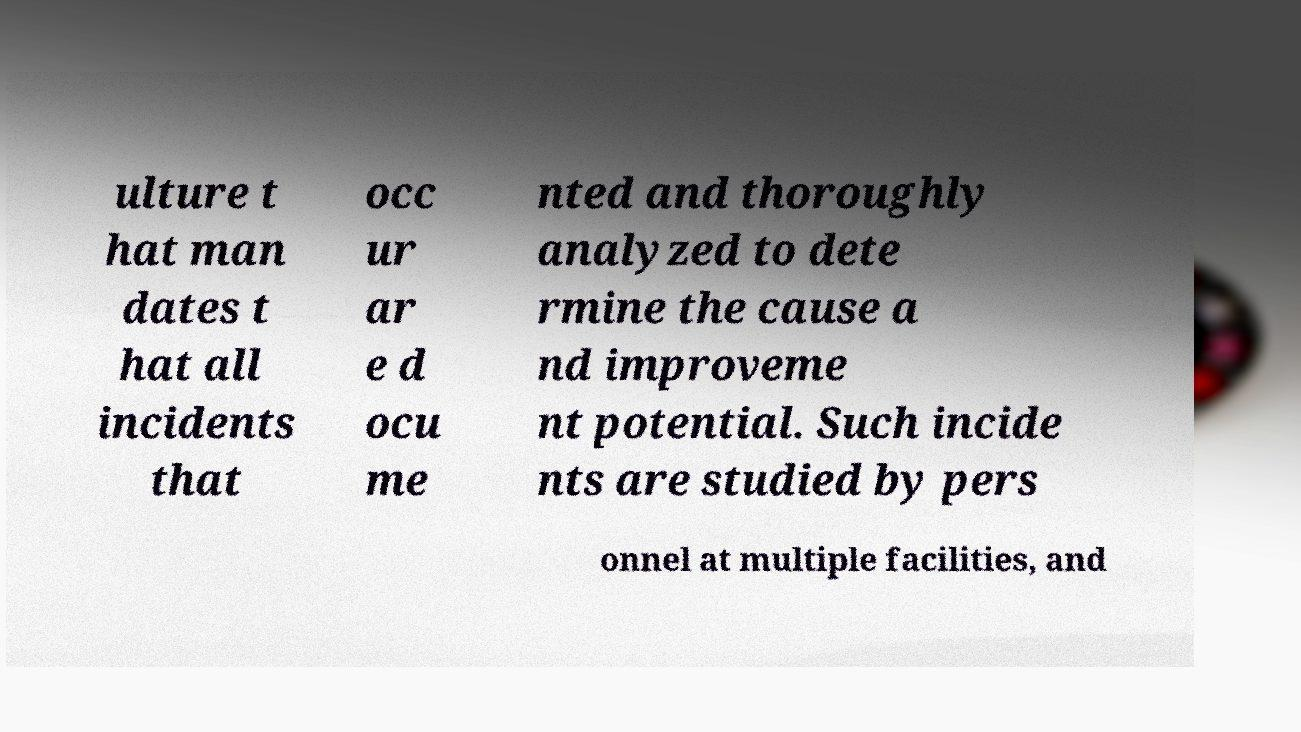Please read and relay the text visible in this image. What does it say? ulture t hat man dates t hat all incidents that occ ur ar e d ocu me nted and thoroughly analyzed to dete rmine the cause a nd improveme nt potential. Such incide nts are studied by pers onnel at multiple facilities, and 